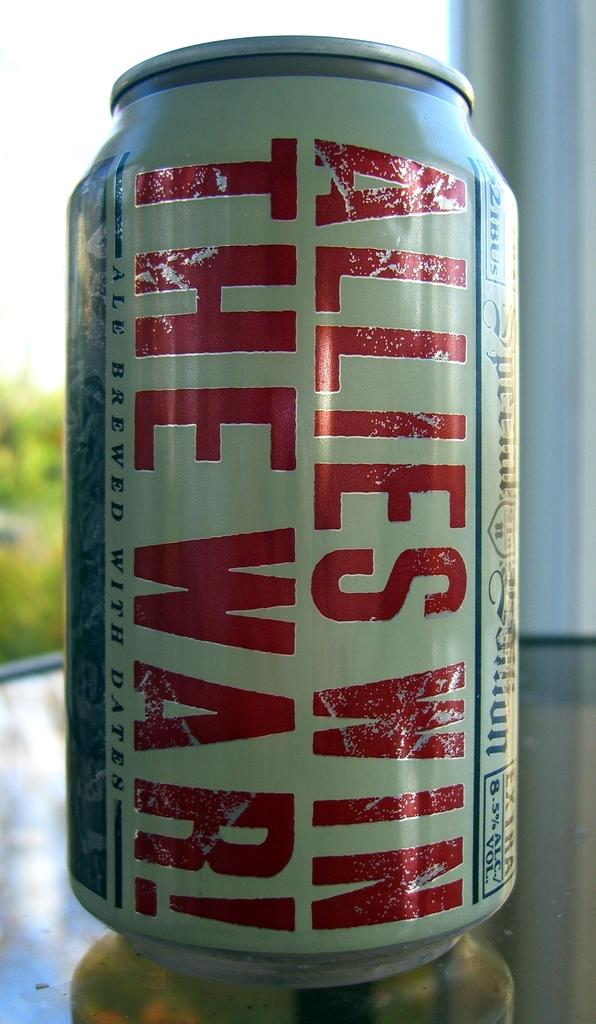<image>
Relay a brief, clear account of the picture shown. A can of ale made with dates labeled," Allies Win The War!" 